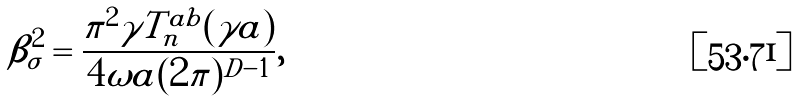Convert formula to latex. <formula><loc_0><loc_0><loc_500><loc_500>\beta _ { \sigma } ^ { 2 } = \frac { \pi ^ { 2 } \gamma T _ { n } ^ { a b } ( \gamma a ) } { 4 \omega a ( 2 \pi ) ^ { D - 1 } } ,</formula> 